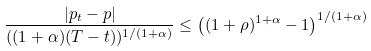<formula> <loc_0><loc_0><loc_500><loc_500>\frac { | p _ { t } - p | } { ( ( 1 + \alpha ) ( T - t ) ) ^ { 1 / ( 1 + \alpha ) } } \leq \left ( ( 1 + \rho ) ^ { 1 + \alpha } - 1 \right ) ^ { 1 / ( 1 + \alpha ) }</formula> 